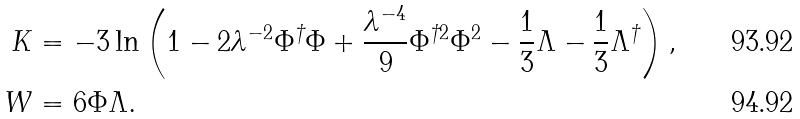<formula> <loc_0><loc_0><loc_500><loc_500>K & = - 3 \ln \left ( 1 - 2 \lambda ^ { - 2 } \Phi ^ { \dagger } \Phi + \frac { \lambda ^ { - 4 } } { 9 } \Phi ^ { \dagger 2 } \Phi ^ { 2 } - \frac { 1 } { 3 } \Lambda - \frac { 1 } { 3 } \Lambda ^ { \dagger } \right ) , \\ W & = 6 \Phi \Lambda .</formula> 